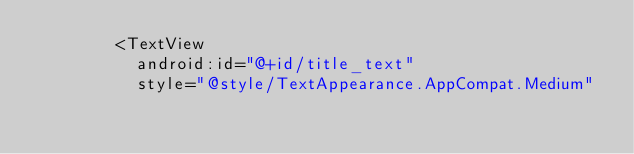Convert code to text. <code><loc_0><loc_0><loc_500><loc_500><_XML_>				<TextView
					android:id="@+id/title_text"
					style="@style/TextAppearance.AppCompat.Medium"</code> 